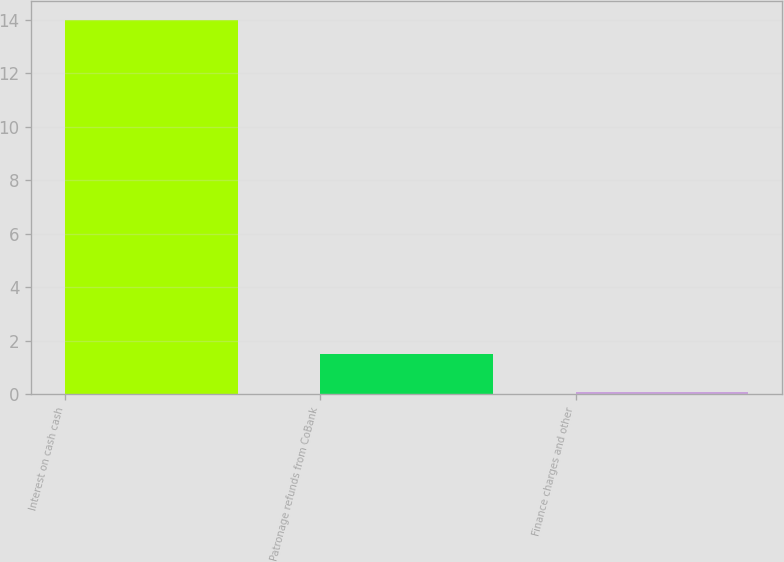Convert chart. <chart><loc_0><loc_0><loc_500><loc_500><bar_chart><fcel>Interest on cash cash<fcel>Patronage refunds from CoBank<fcel>Finance charges and other<nl><fcel>14<fcel>1.49<fcel>0.1<nl></chart> 